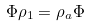<formula> <loc_0><loc_0><loc_500><loc_500>\Phi \rho _ { 1 } = \rho _ { a } \Phi</formula> 